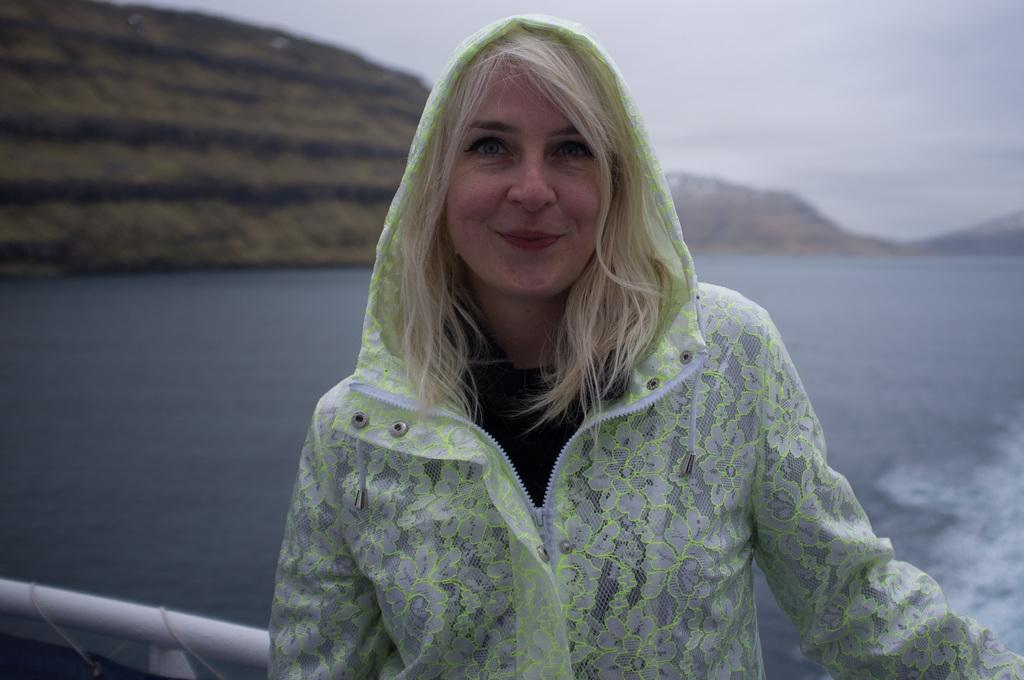Who is present in the image? There is a woman in the image. What is the woman doing in the image? The woman is standing and smiling. What is the woman wearing in the image? The woman is wearing a jersey. What can be seen in the background of the image? There are mountains visible in the background of the image. What is the condition of the water in the image? There appears to be water flowing in the image. What type of pickle can be seen in the woman's hand in the image? There is no pickle present in the image; the woman is not holding anything in her hand. What kind of apparatus is being used by the woman in the image? There is no apparatus visible in the image; the woman is simply standing and smiling. 